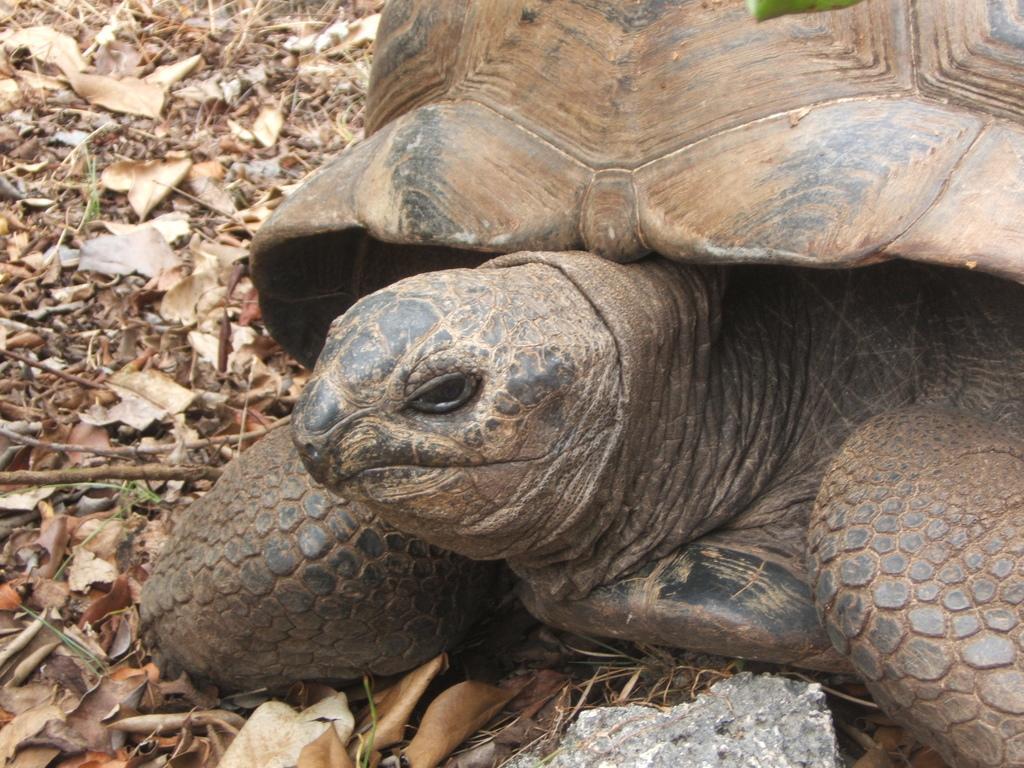Could you give a brief overview of what you see in this image? This picture shows a tortoise. we see stone and few leaves on the ground. 